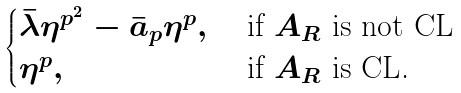<formula> <loc_0><loc_0><loc_500><loc_500>\begin{cases} \bar { \lambda } \eta ^ { p ^ { 2 } } - \bar { a } _ { p } \eta ^ { p } , & \text { if $A_{R}$ is not CL} \\ \eta ^ { p } , & \text { if $A_{R}$ is CL.} \end{cases}</formula> 